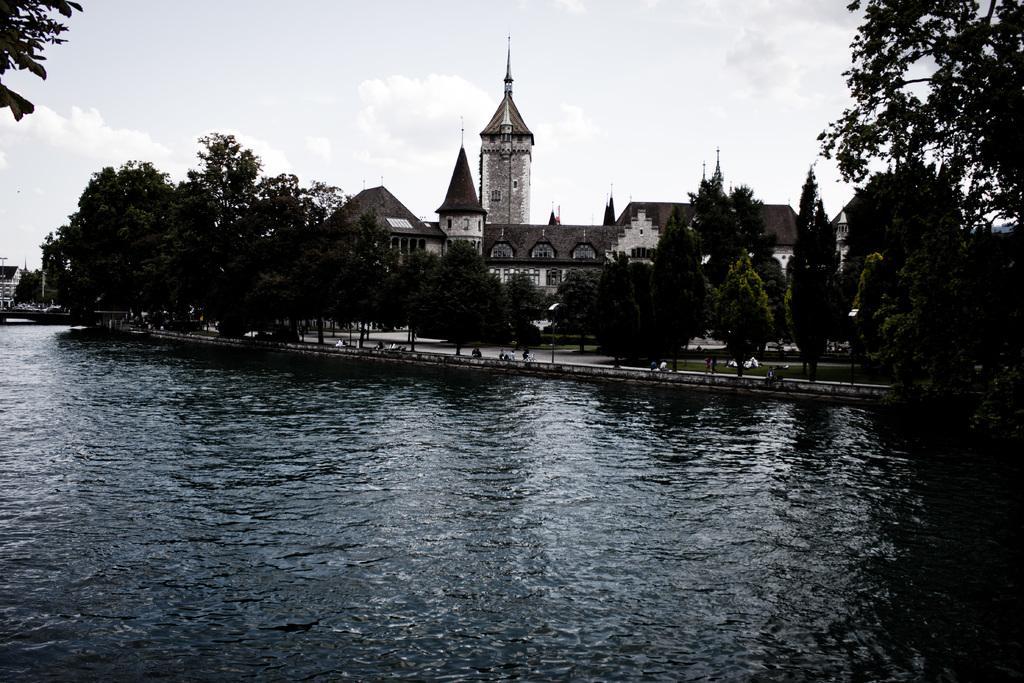Could you give a brief overview of what you see in this image? In the foreground of the picture there is a river. In the center of the picture there are trees, grass and a castle. Sky is cloudy. 